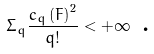<formula> <loc_0><loc_0><loc_500><loc_500>\Sigma _ { q } \frac { c _ { q } \left ( F \right ) ^ { 2 } } { q ! } < + \infty \text { .}</formula> 